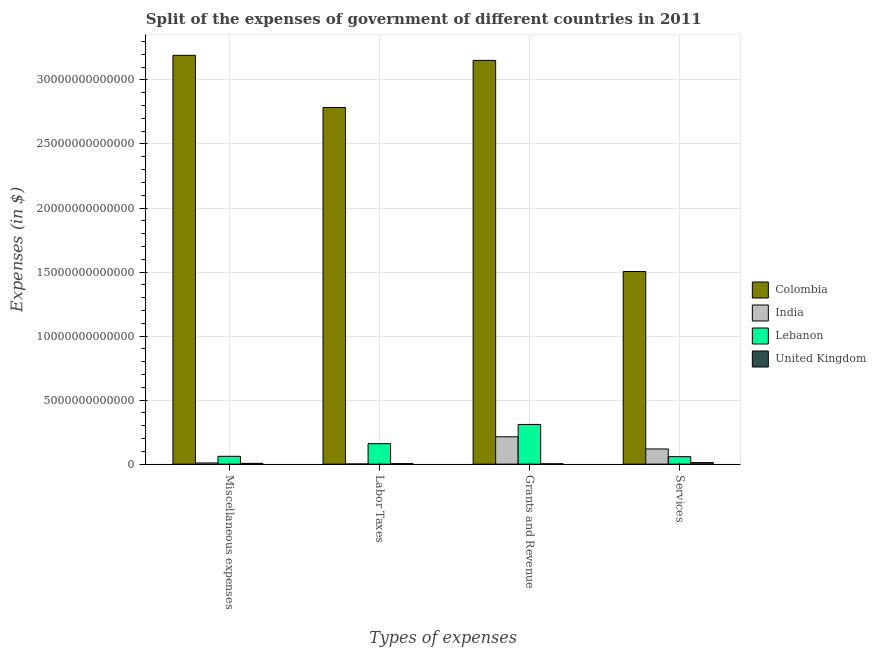How many different coloured bars are there?
Your response must be concise. 4. Are the number of bars on each tick of the X-axis equal?
Give a very brief answer. Yes. How many bars are there on the 3rd tick from the right?
Keep it short and to the point. 4. What is the label of the 2nd group of bars from the left?
Provide a short and direct response. Labor Taxes. What is the amount spent on grants and revenue in Lebanon?
Your answer should be compact. 3.10e+12. Across all countries, what is the maximum amount spent on miscellaneous expenses?
Ensure brevity in your answer.  3.19e+13. Across all countries, what is the minimum amount spent on services?
Keep it short and to the point. 1.18e+11. What is the total amount spent on miscellaneous expenses in the graph?
Your answer should be very brief. 3.27e+13. What is the difference between the amount spent on miscellaneous expenses in Lebanon and that in United Kingdom?
Provide a short and direct response. 5.51e+11. What is the difference between the amount spent on grants and revenue in Colombia and the amount spent on labor taxes in Lebanon?
Provide a succinct answer. 2.99e+13. What is the average amount spent on miscellaneous expenses per country?
Make the answer very short. 8.17e+12. What is the difference between the amount spent on labor taxes and amount spent on services in United Kingdom?
Offer a terse response. -8.11e+1. What is the ratio of the amount spent on services in Lebanon to that in United Kingdom?
Your answer should be compact. 4.94. What is the difference between the highest and the second highest amount spent on services?
Give a very brief answer. 1.39e+13. What is the difference between the highest and the lowest amount spent on grants and revenue?
Your answer should be compact. 3.15e+13. Is the sum of the amount spent on miscellaneous expenses in Lebanon and India greater than the maximum amount spent on labor taxes across all countries?
Your response must be concise. No. Is it the case that in every country, the sum of the amount spent on services and amount spent on labor taxes is greater than the sum of amount spent on grants and revenue and amount spent on miscellaneous expenses?
Provide a succinct answer. No. What does the 3rd bar from the left in Grants and Revenue represents?
Your answer should be compact. Lebanon. What does the 1st bar from the right in Services represents?
Give a very brief answer. United Kingdom. Is it the case that in every country, the sum of the amount spent on miscellaneous expenses and amount spent on labor taxes is greater than the amount spent on grants and revenue?
Make the answer very short. No. Are all the bars in the graph horizontal?
Your answer should be compact. No. How many countries are there in the graph?
Keep it short and to the point. 4. What is the difference between two consecutive major ticks on the Y-axis?
Give a very brief answer. 5.00e+12. How are the legend labels stacked?
Offer a terse response. Vertical. What is the title of the graph?
Your answer should be compact. Split of the expenses of government of different countries in 2011. Does "Czech Republic" appear as one of the legend labels in the graph?
Make the answer very short. No. What is the label or title of the X-axis?
Provide a succinct answer. Types of expenses. What is the label or title of the Y-axis?
Ensure brevity in your answer.  Expenses (in $). What is the Expenses (in $) of Colombia in Miscellaneous expenses?
Offer a terse response. 3.19e+13. What is the Expenses (in $) in India in Miscellaneous expenses?
Offer a very short reply. 8.96e+1. What is the Expenses (in $) of Lebanon in Miscellaneous expenses?
Offer a terse response. 6.10e+11. What is the Expenses (in $) in United Kingdom in Miscellaneous expenses?
Provide a short and direct response. 5.83e+1. What is the Expenses (in $) of Colombia in Labor Taxes?
Keep it short and to the point. 2.78e+13. What is the Expenses (in $) of India in Labor Taxes?
Offer a very short reply. 8.41e+09. What is the Expenses (in $) in Lebanon in Labor Taxes?
Provide a succinct answer. 1.60e+12. What is the Expenses (in $) in United Kingdom in Labor Taxes?
Ensure brevity in your answer.  3.68e+1. What is the Expenses (in $) in Colombia in Grants and Revenue?
Your answer should be compact. 3.15e+13. What is the Expenses (in $) in India in Grants and Revenue?
Your answer should be compact. 2.14e+12. What is the Expenses (in $) in Lebanon in Grants and Revenue?
Your response must be concise. 3.10e+12. What is the Expenses (in $) in United Kingdom in Grants and Revenue?
Offer a very short reply. 2.42e+1. What is the Expenses (in $) of Colombia in Services?
Offer a very short reply. 1.50e+13. What is the Expenses (in $) of India in Services?
Keep it short and to the point. 1.18e+12. What is the Expenses (in $) in Lebanon in Services?
Keep it short and to the point. 5.82e+11. What is the Expenses (in $) in United Kingdom in Services?
Your answer should be very brief. 1.18e+11. Across all Types of expenses, what is the maximum Expenses (in $) of Colombia?
Keep it short and to the point. 3.19e+13. Across all Types of expenses, what is the maximum Expenses (in $) in India?
Keep it short and to the point. 2.14e+12. Across all Types of expenses, what is the maximum Expenses (in $) of Lebanon?
Ensure brevity in your answer.  3.10e+12. Across all Types of expenses, what is the maximum Expenses (in $) of United Kingdom?
Provide a succinct answer. 1.18e+11. Across all Types of expenses, what is the minimum Expenses (in $) in Colombia?
Offer a very short reply. 1.50e+13. Across all Types of expenses, what is the minimum Expenses (in $) of India?
Make the answer very short. 8.41e+09. Across all Types of expenses, what is the minimum Expenses (in $) in Lebanon?
Your answer should be compact. 5.82e+11. Across all Types of expenses, what is the minimum Expenses (in $) of United Kingdom?
Give a very brief answer. 2.42e+1. What is the total Expenses (in $) in Colombia in the graph?
Your response must be concise. 1.06e+14. What is the total Expenses (in $) of India in the graph?
Provide a succinct answer. 3.42e+12. What is the total Expenses (in $) of Lebanon in the graph?
Provide a short and direct response. 5.89e+12. What is the total Expenses (in $) of United Kingdom in the graph?
Your response must be concise. 2.37e+11. What is the difference between the Expenses (in $) in Colombia in Miscellaneous expenses and that in Labor Taxes?
Offer a very short reply. 4.08e+12. What is the difference between the Expenses (in $) of India in Miscellaneous expenses and that in Labor Taxes?
Your response must be concise. 8.12e+1. What is the difference between the Expenses (in $) of Lebanon in Miscellaneous expenses and that in Labor Taxes?
Offer a very short reply. -9.89e+11. What is the difference between the Expenses (in $) in United Kingdom in Miscellaneous expenses and that in Labor Taxes?
Your response must be concise. 2.15e+1. What is the difference between the Expenses (in $) of Colombia in Miscellaneous expenses and that in Grants and Revenue?
Give a very brief answer. 3.94e+11. What is the difference between the Expenses (in $) in India in Miscellaneous expenses and that in Grants and Revenue?
Provide a short and direct response. -2.05e+12. What is the difference between the Expenses (in $) of Lebanon in Miscellaneous expenses and that in Grants and Revenue?
Your answer should be compact. -2.49e+12. What is the difference between the Expenses (in $) of United Kingdom in Miscellaneous expenses and that in Grants and Revenue?
Your answer should be compact. 3.41e+1. What is the difference between the Expenses (in $) in Colombia in Miscellaneous expenses and that in Services?
Give a very brief answer. 1.69e+13. What is the difference between the Expenses (in $) of India in Miscellaneous expenses and that in Services?
Ensure brevity in your answer.  -1.09e+12. What is the difference between the Expenses (in $) of Lebanon in Miscellaneous expenses and that in Services?
Your response must be concise. 2.76e+1. What is the difference between the Expenses (in $) of United Kingdom in Miscellaneous expenses and that in Services?
Your answer should be compact. -5.96e+1. What is the difference between the Expenses (in $) in Colombia in Labor Taxes and that in Grants and Revenue?
Keep it short and to the point. -3.68e+12. What is the difference between the Expenses (in $) in India in Labor Taxes and that in Grants and Revenue?
Ensure brevity in your answer.  -2.13e+12. What is the difference between the Expenses (in $) in Lebanon in Labor Taxes and that in Grants and Revenue?
Your answer should be compact. -1.50e+12. What is the difference between the Expenses (in $) in United Kingdom in Labor Taxes and that in Grants and Revenue?
Your answer should be very brief. 1.26e+1. What is the difference between the Expenses (in $) in Colombia in Labor Taxes and that in Services?
Provide a short and direct response. 1.28e+13. What is the difference between the Expenses (in $) in India in Labor Taxes and that in Services?
Ensure brevity in your answer.  -1.18e+12. What is the difference between the Expenses (in $) of Lebanon in Labor Taxes and that in Services?
Provide a short and direct response. 1.02e+12. What is the difference between the Expenses (in $) of United Kingdom in Labor Taxes and that in Services?
Keep it short and to the point. -8.11e+1. What is the difference between the Expenses (in $) in Colombia in Grants and Revenue and that in Services?
Your answer should be compact. 1.65e+13. What is the difference between the Expenses (in $) in India in Grants and Revenue and that in Services?
Keep it short and to the point. 9.52e+11. What is the difference between the Expenses (in $) in Lebanon in Grants and Revenue and that in Services?
Ensure brevity in your answer.  2.52e+12. What is the difference between the Expenses (in $) in United Kingdom in Grants and Revenue and that in Services?
Keep it short and to the point. -9.37e+1. What is the difference between the Expenses (in $) in Colombia in Miscellaneous expenses and the Expenses (in $) in India in Labor Taxes?
Offer a terse response. 3.19e+13. What is the difference between the Expenses (in $) in Colombia in Miscellaneous expenses and the Expenses (in $) in Lebanon in Labor Taxes?
Offer a terse response. 3.03e+13. What is the difference between the Expenses (in $) in Colombia in Miscellaneous expenses and the Expenses (in $) in United Kingdom in Labor Taxes?
Provide a succinct answer. 3.19e+13. What is the difference between the Expenses (in $) in India in Miscellaneous expenses and the Expenses (in $) in Lebanon in Labor Taxes?
Your response must be concise. -1.51e+12. What is the difference between the Expenses (in $) of India in Miscellaneous expenses and the Expenses (in $) of United Kingdom in Labor Taxes?
Your answer should be very brief. 5.28e+1. What is the difference between the Expenses (in $) of Lebanon in Miscellaneous expenses and the Expenses (in $) of United Kingdom in Labor Taxes?
Offer a very short reply. 5.73e+11. What is the difference between the Expenses (in $) of Colombia in Miscellaneous expenses and the Expenses (in $) of India in Grants and Revenue?
Your answer should be compact. 2.98e+13. What is the difference between the Expenses (in $) in Colombia in Miscellaneous expenses and the Expenses (in $) in Lebanon in Grants and Revenue?
Your answer should be compact. 2.88e+13. What is the difference between the Expenses (in $) of Colombia in Miscellaneous expenses and the Expenses (in $) of United Kingdom in Grants and Revenue?
Ensure brevity in your answer.  3.19e+13. What is the difference between the Expenses (in $) of India in Miscellaneous expenses and the Expenses (in $) of Lebanon in Grants and Revenue?
Offer a very short reply. -3.01e+12. What is the difference between the Expenses (in $) of India in Miscellaneous expenses and the Expenses (in $) of United Kingdom in Grants and Revenue?
Provide a short and direct response. 6.54e+1. What is the difference between the Expenses (in $) of Lebanon in Miscellaneous expenses and the Expenses (in $) of United Kingdom in Grants and Revenue?
Give a very brief answer. 5.85e+11. What is the difference between the Expenses (in $) of Colombia in Miscellaneous expenses and the Expenses (in $) of India in Services?
Provide a succinct answer. 3.07e+13. What is the difference between the Expenses (in $) of Colombia in Miscellaneous expenses and the Expenses (in $) of Lebanon in Services?
Your response must be concise. 3.13e+13. What is the difference between the Expenses (in $) in Colombia in Miscellaneous expenses and the Expenses (in $) in United Kingdom in Services?
Provide a succinct answer. 3.18e+13. What is the difference between the Expenses (in $) of India in Miscellaneous expenses and the Expenses (in $) of Lebanon in Services?
Ensure brevity in your answer.  -4.92e+11. What is the difference between the Expenses (in $) of India in Miscellaneous expenses and the Expenses (in $) of United Kingdom in Services?
Offer a very short reply. -2.83e+1. What is the difference between the Expenses (in $) of Lebanon in Miscellaneous expenses and the Expenses (in $) of United Kingdom in Services?
Your answer should be very brief. 4.92e+11. What is the difference between the Expenses (in $) of Colombia in Labor Taxes and the Expenses (in $) of India in Grants and Revenue?
Ensure brevity in your answer.  2.57e+13. What is the difference between the Expenses (in $) in Colombia in Labor Taxes and the Expenses (in $) in Lebanon in Grants and Revenue?
Your answer should be very brief. 2.47e+13. What is the difference between the Expenses (in $) of Colombia in Labor Taxes and the Expenses (in $) of United Kingdom in Grants and Revenue?
Provide a succinct answer. 2.78e+13. What is the difference between the Expenses (in $) in India in Labor Taxes and the Expenses (in $) in Lebanon in Grants and Revenue?
Offer a very short reply. -3.09e+12. What is the difference between the Expenses (in $) of India in Labor Taxes and the Expenses (in $) of United Kingdom in Grants and Revenue?
Give a very brief answer. -1.58e+1. What is the difference between the Expenses (in $) in Lebanon in Labor Taxes and the Expenses (in $) in United Kingdom in Grants and Revenue?
Your response must be concise. 1.57e+12. What is the difference between the Expenses (in $) in Colombia in Labor Taxes and the Expenses (in $) in India in Services?
Offer a terse response. 2.67e+13. What is the difference between the Expenses (in $) of Colombia in Labor Taxes and the Expenses (in $) of Lebanon in Services?
Make the answer very short. 2.73e+13. What is the difference between the Expenses (in $) in Colombia in Labor Taxes and the Expenses (in $) in United Kingdom in Services?
Keep it short and to the point. 2.77e+13. What is the difference between the Expenses (in $) in India in Labor Taxes and the Expenses (in $) in Lebanon in Services?
Ensure brevity in your answer.  -5.74e+11. What is the difference between the Expenses (in $) of India in Labor Taxes and the Expenses (in $) of United Kingdom in Services?
Your answer should be compact. -1.10e+11. What is the difference between the Expenses (in $) of Lebanon in Labor Taxes and the Expenses (in $) of United Kingdom in Services?
Your response must be concise. 1.48e+12. What is the difference between the Expenses (in $) of Colombia in Grants and Revenue and the Expenses (in $) of India in Services?
Your response must be concise. 3.03e+13. What is the difference between the Expenses (in $) of Colombia in Grants and Revenue and the Expenses (in $) of Lebanon in Services?
Provide a short and direct response. 3.09e+13. What is the difference between the Expenses (in $) in Colombia in Grants and Revenue and the Expenses (in $) in United Kingdom in Services?
Make the answer very short. 3.14e+13. What is the difference between the Expenses (in $) in India in Grants and Revenue and the Expenses (in $) in Lebanon in Services?
Make the answer very short. 1.55e+12. What is the difference between the Expenses (in $) of India in Grants and Revenue and the Expenses (in $) of United Kingdom in Services?
Offer a very short reply. 2.02e+12. What is the difference between the Expenses (in $) in Lebanon in Grants and Revenue and the Expenses (in $) in United Kingdom in Services?
Offer a very short reply. 2.98e+12. What is the average Expenses (in $) of Colombia per Types of expenses?
Offer a terse response. 2.66e+13. What is the average Expenses (in $) of India per Types of expenses?
Keep it short and to the point. 8.54e+11. What is the average Expenses (in $) in Lebanon per Types of expenses?
Give a very brief answer. 1.47e+12. What is the average Expenses (in $) in United Kingdom per Types of expenses?
Ensure brevity in your answer.  5.93e+1. What is the difference between the Expenses (in $) of Colombia and Expenses (in $) of India in Miscellaneous expenses?
Offer a terse response. 3.18e+13. What is the difference between the Expenses (in $) in Colombia and Expenses (in $) in Lebanon in Miscellaneous expenses?
Your response must be concise. 3.13e+13. What is the difference between the Expenses (in $) of Colombia and Expenses (in $) of United Kingdom in Miscellaneous expenses?
Offer a terse response. 3.19e+13. What is the difference between the Expenses (in $) of India and Expenses (in $) of Lebanon in Miscellaneous expenses?
Give a very brief answer. -5.20e+11. What is the difference between the Expenses (in $) of India and Expenses (in $) of United Kingdom in Miscellaneous expenses?
Make the answer very short. 3.13e+1. What is the difference between the Expenses (in $) in Lebanon and Expenses (in $) in United Kingdom in Miscellaneous expenses?
Your answer should be very brief. 5.51e+11. What is the difference between the Expenses (in $) of Colombia and Expenses (in $) of India in Labor Taxes?
Give a very brief answer. 2.78e+13. What is the difference between the Expenses (in $) of Colombia and Expenses (in $) of Lebanon in Labor Taxes?
Give a very brief answer. 2.62e+13. What is the difference between the Expenses (in $) of Colombia and Expenses (in $) of United Kingdom in Labor Taxes?
Your answer should be compact. 2.78e+13. What is the difference between the Expenses (in $) in India and Expenses (in $) in Lebanon in Labor Taxes?
Your answer should be very brief. -1.59e+12. What is the difference between the Expenses (in $) in India and Expenses (in $) in United Kingdom in Labor Taxes?
Keep it short and to the point. -2.84e+1. What is the difference between the Expenses (in $) in Lebanon and Expenses (in $) in United Kingdom in Labor Taxes?
Make the answer very short. 1.56e+12. What is the difference between the Expenses (in $) of Colombia and Expenses (in $) of India in Grants and Revenue?
Ensure brevity in your answer.  2.94e+13. What is the difference between the Expenses (in $) of Colombia and Expenses (in $) of Lebanon in Grants and Revenue?
Offer a very short reply. 2.84e+13. What is the difference between the Expenses (in $) of Colombia and Expenses (in $) of United Kingdom in Grants and Revenue?
Offer a very short reply. 3.15e+13. What is the difference between the Expenses (in $) of India and Expenses (in $) of Lebanon in Grants and Revenue?
Ensure brevity in your answer.  -9.64e+11. What is the difference between the Expenses (in $) in India and Expenses (in $) in United Kingdom in Grants and Revenue?
Provide a succinct answer. 2.11e+12. What is the difference between the Expenses (in $) in Lebanon and Expenses (in $) in United Kingdom in Grants and Revenue?
Keep it short and to the point. 3.08e+12. What is the difference between the Expenses (in $) in Colombia and Expenses (in $) in India in Services?
Give a very brief answer. 1.39e+13. What is the difference between the Expenses (in $) in Colombia and Expenses (in $) in Lebanon in Services?
Your answer should be compact. 1.45e+13. What is the difference between the Expenses (in $) of Colombia and Expenses (in $) of United Kingdom in Services?
Offer a terse response. 1.49e+13. What is the difference between the Expenses (in $) of India and Expenses (in $) of Lebanon in Services?
Provide a succinct answer. 6.02e+11. What is the difference between the Expenses (in $) in India and Expenses (in $) in United Kingdom in Services?
Provide a succinct answer. 1.07e+12. What is the difference between the Expenses (in $) of Lebanon and Expenses (in $) of United Kingdom in Services?
Keep it short and to the point. 4.64e+11. What is the ratio of the Expenses (in $) of Colombia in Miscellaneous expenses to that in Labor Taxes?
Offer a very short reply. 1.15. What is the ratio of the Expenses (in $) in India in Miscellaneous expenses to that in Labor Taxes?
Keep it short and to the point. 10.66. What is the ratio of the Expenses (in $) in Lebanon in Miscellaneous expenses to that in Labor Taxes?
Keep it short and to the point. 0.38. What is the ratio of the Expenses (in $) in United Kingdom in Miscellaneous expenses to that in Labor Taxes?
Your answer should be compact. 1.58. What is the ratio of the Expenses (in $) of Colombia in Miscellaneous expenses to that in Grants and Revenue?
Provide a short and direct response. 1.01. What is the ratio of the Expenses (in $) of India in Miscellaneous expenses to that in Grants and Revenue?
Give a very brief answer. 0.04. What is the ratio of the Expenses (in $) of Lebanon in Miscellaneous expenses to that in Grants and Revenue?
Provide a short and direct response. 0.2. What is the ratio of the Expenses (in $) in United Kingdom in Miscellaneous expenses to that in Grants and Revenue?
Your response must be concise. 2.41. What is the ratio of the Expenses (in $) of Colombia in Miscellaneous expenses to that in Services?
Ensure brevity in your answer.  2.12. What is the ratio of the Expenses (in $) in India in Miscellaneous expenses to that in Services?
Make the answer very short. 0.08. What is the ratio of the Expenses (in $) of Lebanon in Miscellaneous expenses to that in Services?
Your answer should be very brief. 1.05. What is the ratio of the Expenses (in $) in United Kingdom in Miscellaneous expenses to that in Services?
Your response must be concise. 0.49. What is the ratio of the Expenses (in $) in Colombia in Labor Taxes to that in Grants and Revenue?
Provide a succinct answer. 0.88. What is the ratio of the Expenses (in $) in India in Labor Taxes to that in Grants and Revenue?
Keep it short and to the point. 0. What is the ratio of the Expenses (in $) in Lebanon in Labor Taxes to that in Grants and Revenue?
Your answer should be compact. 0.52. What is the ratio of the Expenses (in $) of United Kingdom in Labor Taxes to that in Grants and Revenue?
Your response must be concise. 1.52. What is the ratio of the Expenses (in $) of Colombia in Labor Taxes to that in Services?
Make the answer very short. 1.85. What is the ratio of the Expenses (in $) in India in Labor Taxes to that in Services?
Make the answer very short. 0.01. What is the ratio of the Expenses (in $) of Lebanon in Labor Taxes to that in Services?
Make the answer very short. 2.75. What is the ratio of the Expenses (in $) in United Kingdom in Labor Taxes to that in Services?
Provide a short and direct response. 0.31. What is the ratio of the Expenses (in $) of Colombia in Grants and Revenue to that in Services?
Your answer should be very brief. 2.1. What is the ratio of the Expenses (in $) in India in Grants and Revenue to that in Services?
Provide a succinct answer. 1.8. What is the ratio of the Expenses (in $) in Lebanon in Grants and Revenue to that in Services?
Offer a very short reply. 5.33. What is the ratio of the Expenses (in $) of United Kingdom in Grants and Revenue to that in Services?
Offer a terse response. 0.21. What is the difference between the highest and the second highest Expenses (in $) of Colombia?
Ensure brevity in your answer.  3.94e+11. What is the difference between the highest and the second highest Expenses (in $) of India?
Offer a terse response. 9.52e+11. What is the difference between the highest and the second highest Expenses (in $) in Lebanon?
Your answer should be compact. 1.50e+12. What is the difference between the highest and the second highest Expenses (in $) of United Kingdom?
Provide a short and direct response. 5.96e+1. What is the difference between the highest and the lowest Expenses (in $) of Colombia?
Your answer should be compact. 1.69e+13. What is the difference between the highest and the lowest Expenses (in $) in India?
Offer a terse response. 2.13e+12. What is the difference between the highest and the lowest Expenses (in $) of Lebanon?
Offer a very short reply. 2.52e+12. What is the difference between the highest and the lowest Expenses (in $) in United Kingdom?
Provide a succinct answer. 9.37e+1. 